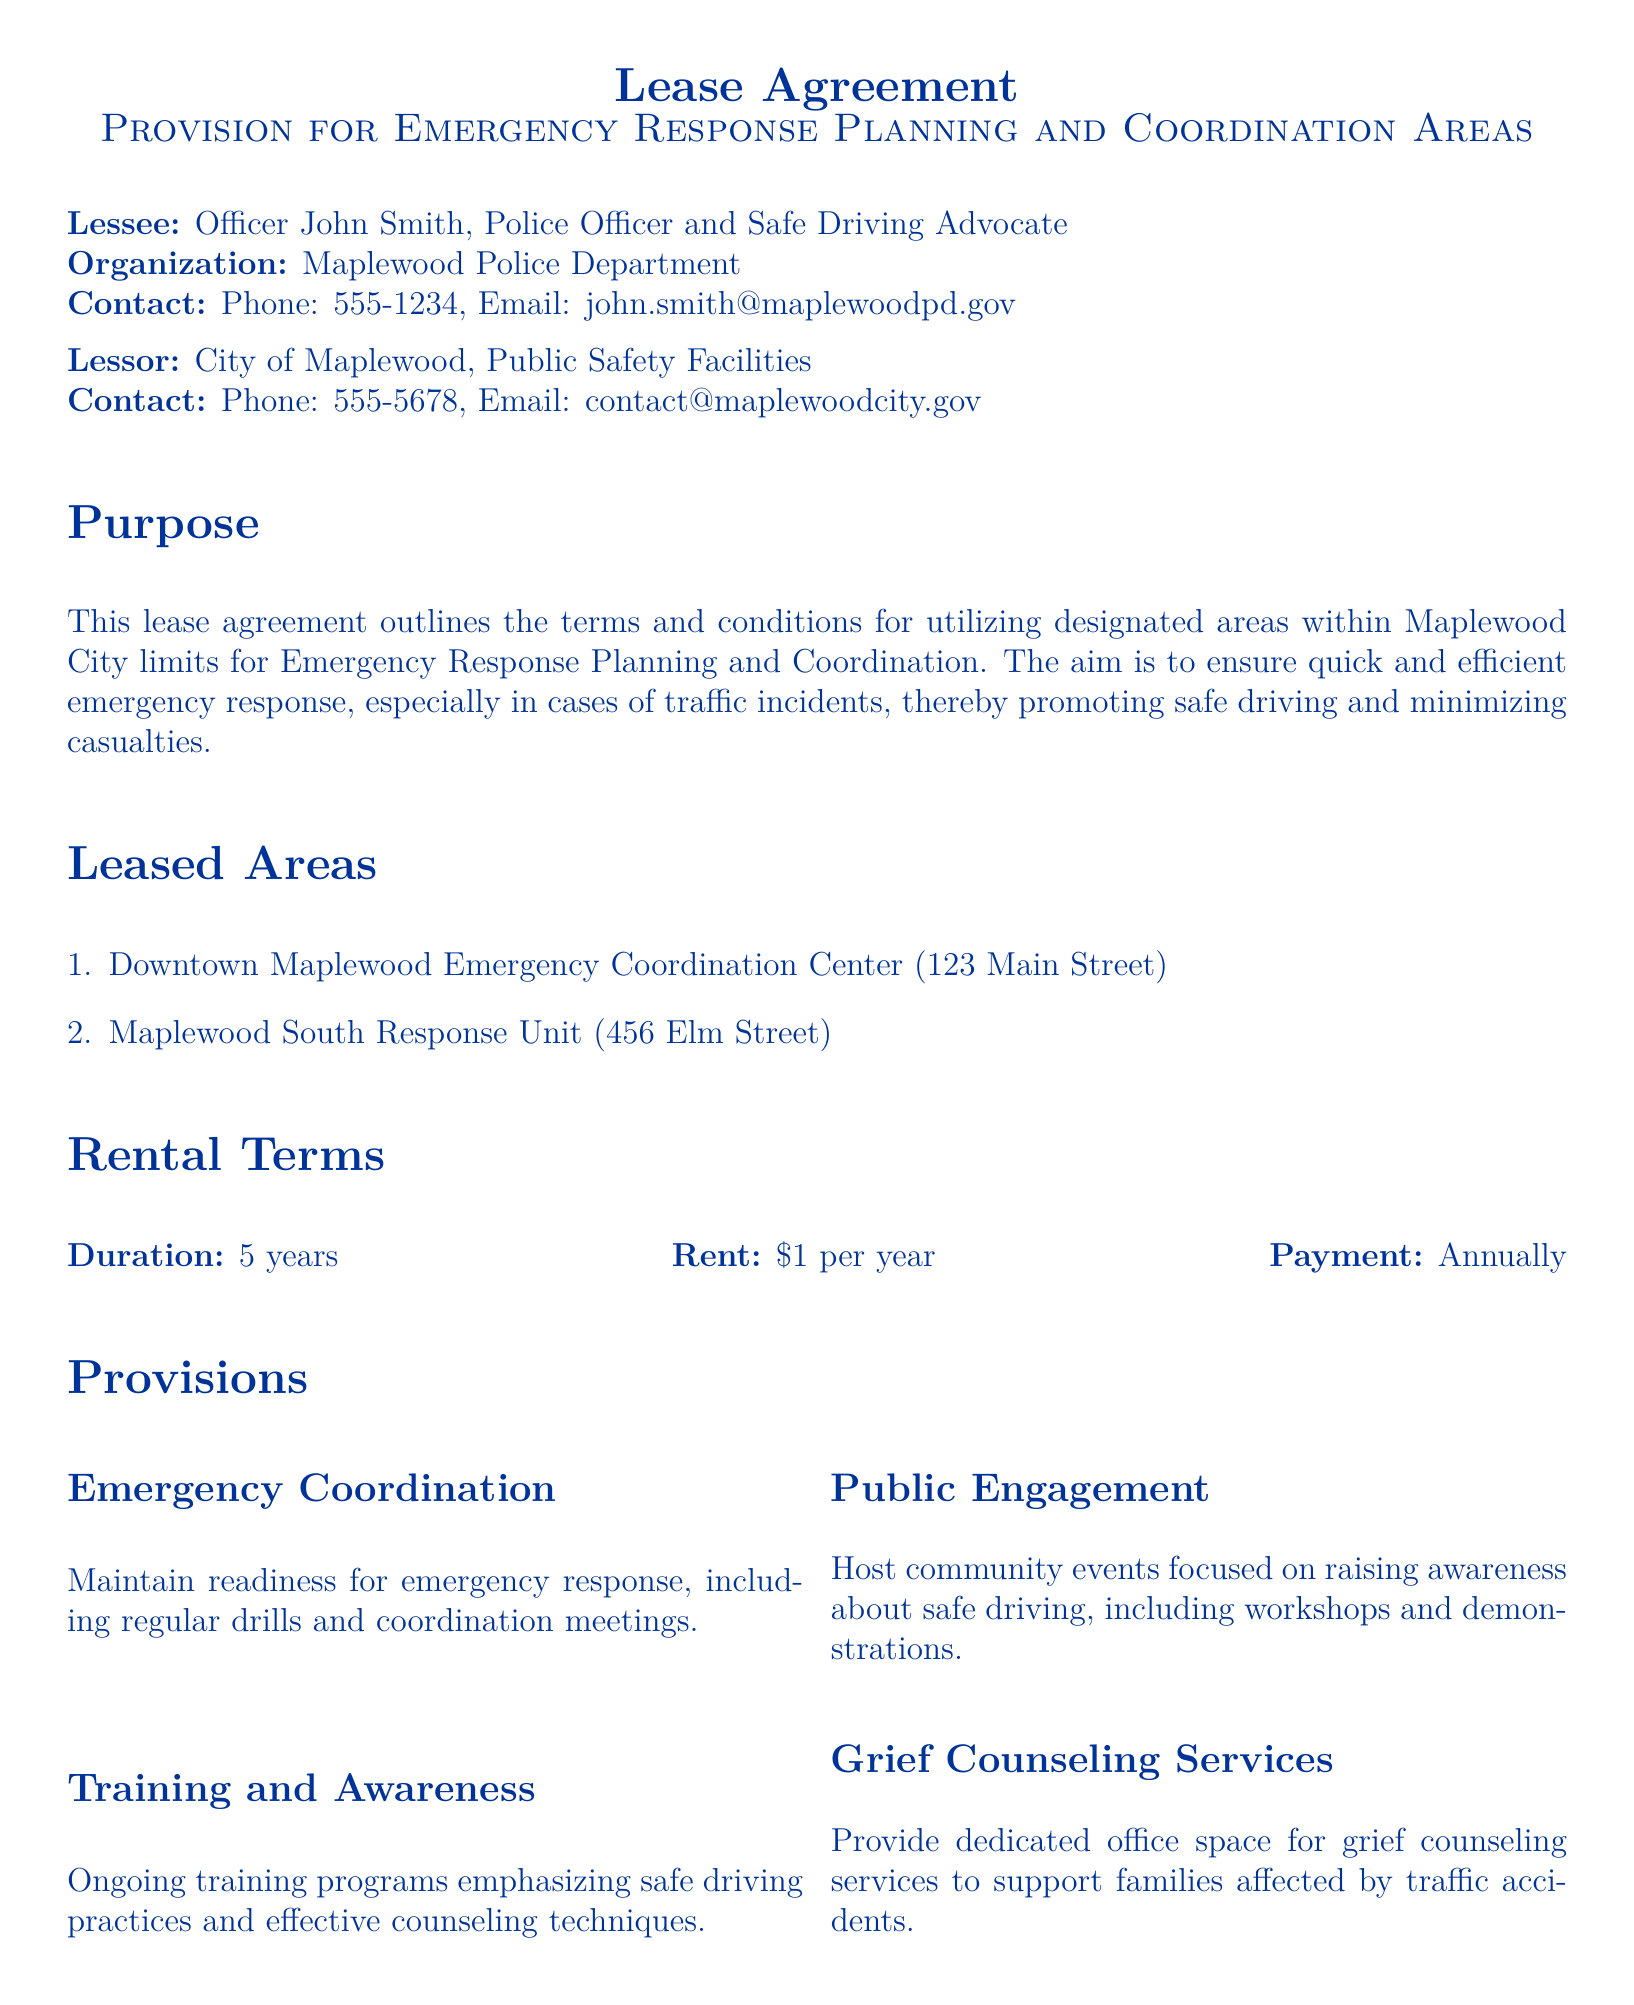What is the lessee's name? The lessee is identified as Officer John Smith in the document.
Answer: Officer John Smith Who is the lessor? The lessor is identified as the City of Maplewood, Public Safety Facilities in the document.
Answer: City of Maplewood, Public Safety Facilities What is the duration of the lease? The duration of the lease is stated as 5 years.
Answer: 5 years What is the annual rent? The annual rent amount is specified in the document.
Answer: $1 Where is the Downtown Maplewood Emergency Coordination Center located? The location of Downtown Maplewood Emergency Coordination Center is given as 123 Main Street.
Answer: 123 Main Street What type of services will be provided for grief counseling? The document mentions specific services related to grief counseling for families affected by traffic accidents.
Answer: Dedicated office space What are the training programs focused on? The ongoing training programs are aimed at specific practices highlighted in the document.
Answer: Safe driving practices What is the purpose of this lease agreement? The purpose of the lease is outlined in the document, emphasizing emergency response.
Answer: Emergency Response Planning and Coordination What date was the lease agreement signed? The date of signing for both parties is stated explicitly in the document.
Answer: September 21, 2023 